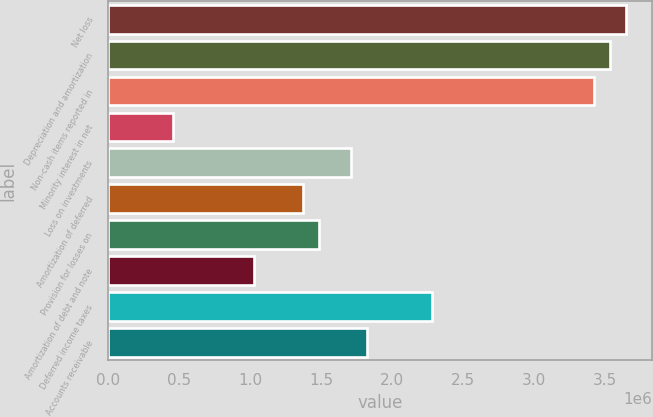<chart> <loc_0><loc_0><loc_500><loc_500><bar_chart><fcel>Net loss<fcel>Depreciation and amortization<fcel>Non-cash items reported in<fcel>Minority interest in net<fcel>Loss on investments<fcel>Amortization of deferred<fcel>Provision for losses on<fcel>Amortization of debt and note<fcel>Deferred income taxes<fcel>Accounts receivable<nl><fcel>3.65294e+06<fcel>3.5388e+06<fcel>3.42466e+06<fcel>457044<fcel>1.71257e+06<fcel>1.37016e+06<fcel>1.4843e+06<fcel>1.02774e+06<fcel>2.28327e+06<fcel>1.82671e+06<nl></chart> 